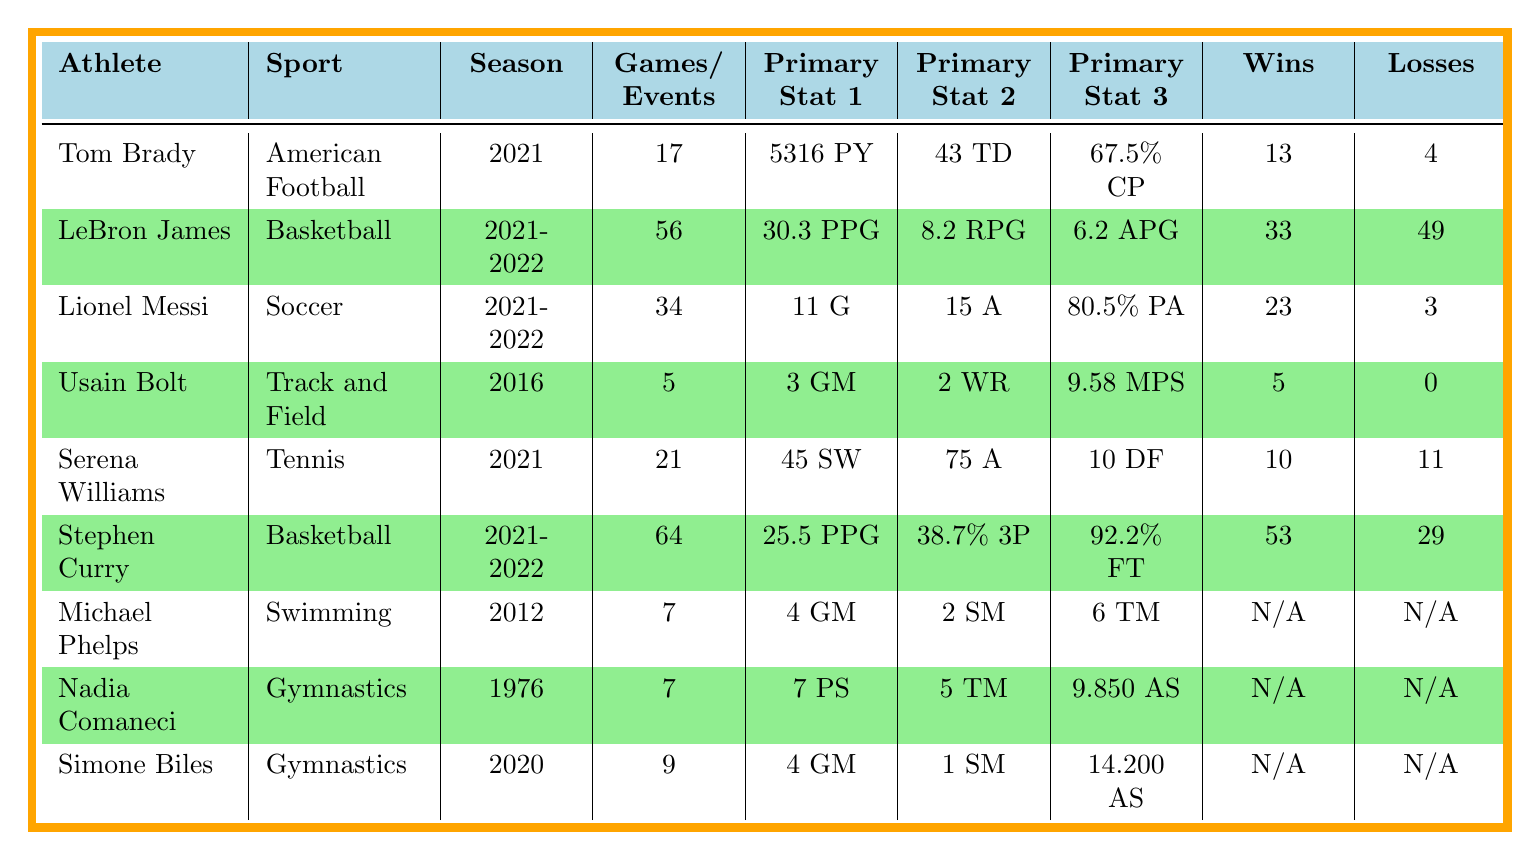What sport did Tom Brady play? Tom Brady is listed in the athlete performance metrics table, and the sport associated with his performance is explicitly stated as American Football.
Answer: American Football How many touchdowns did LeBron James have in the 2021-2022 season? LeBron James's performance metrics show that he had a primary stat of 30.3 points per game, but the table does not provide a touchdown metric as it is not applicable to basketball; thus, this query is misleading.
Answer: N/A Which athlete had the highest completion percentage? The table lists Tom Brady with a passing completion percentage of 67.5, which is the highest complete percentage displayed in the metrics, compared to other sports.
Answer: Tom Brady What is the total number of wins by Stephen Curry and LeBron James combined? Stephen Curry is listed with 53 wins, and LeBron James has 33 wins. Adding these together gives 53 + 33 = 86 total wins.
Answer: 86 Did Simone Biles win more gold medals than Nadia Comaneci? Simone Biles has 4 gold medals while Nadia Comaneci has 5 gold medals according to their respective metrics in the table. Comparing these shows that Biles won fewer gold medals than Comaneci.
Answer: No How many total games or events did Tom Brady and Serena Williams participate in during their respective seasons? Tom Brady played 17 games, and Serena Williams played 21 matches. Adding these together gives 17 + 21 = 38 total games/events.
Answer: 38 What percentage of points per game did Stephen Curry achieve? The table specifies that Stephen Curry scored an average of 25.5 points per game, which is directly provided in the performance metrics under his entry.
Answer: 25.5 points per game Who had the best assist per game ratio in their season? LeBron James had 6.2 assists per game and Stephen Curry had 6.3 assists per game. Comparing the two, Stephen Curry had the higher assist ratio.
Answer: Stephen Curry What was the average score of Nadia Comaneci? The average score for Nadia Comaneci is clearly listed in the table as 9.850 according to the metrics associated with her performance.
Answer: 9.850 If you combine the total medals won by Michael Phelps and Simone Biles, what does the total add up to? Michael Phelps has a total of 6 medals, and Simone Biles won 4 gold and 1 silver, summing to 5 total medals. Therefore, the combined total is 6 + 5 = 11 medals.
Answer: 11 